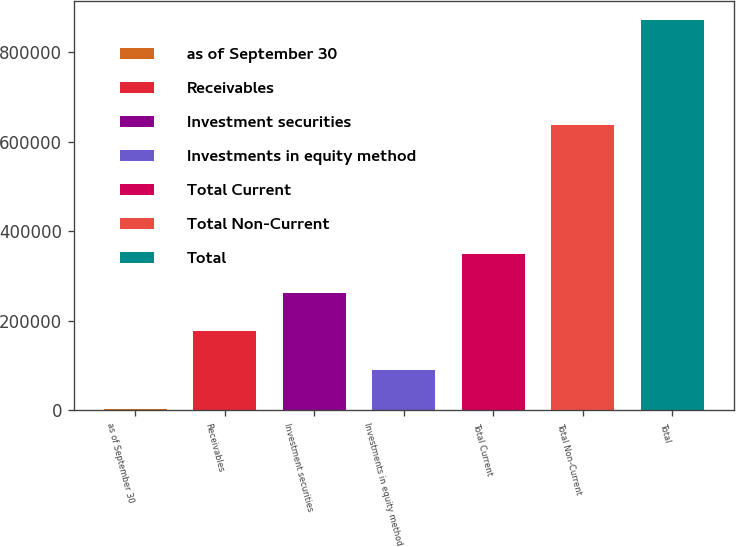Convert chart to OTSL. <chart><loc_0><loc_0><loc_500><loc_500><bar_chart><fcel>as of September 30<fcel>Receivables<fcel>Investment securities<fcel>Investments in equity method<fcel>Total Current<fcel>Total Non-Current<fcel>Total<nl><fcel>2010<fcel>175928<fcel>262887<fcel>88969.1<fcel>349846<fcel>637393<fcel>871601<nl></chart> 